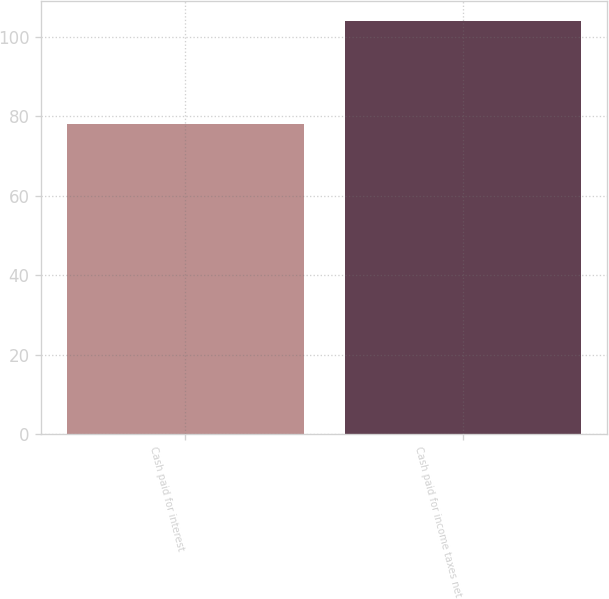Convert chart. <chart><loc_0><loc_0><loc_500><loc_500><bar_chart><fcel>Cash paid for interest<fcel>Cash paid for income taxes net<nl><fcel>78.1<fcel>103.9<nl></chart> 